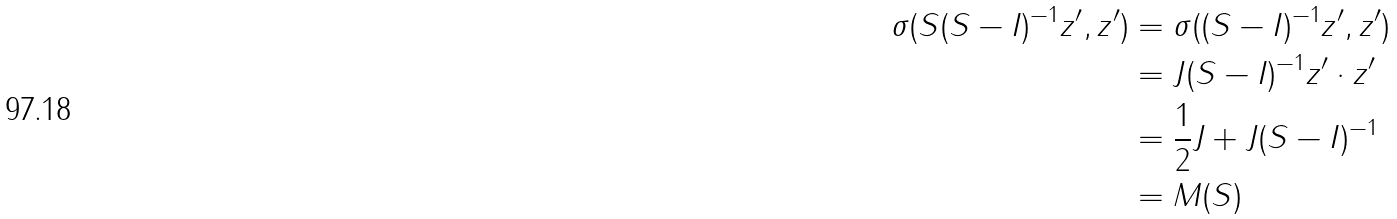<formula> <loc_0><loc_0><loc_500><loc_500>\sigma ( S ( S - I ) ^ { - 1 } z ^ { \prime } , z ^ { \prime } ) & = \sigma ( ( S - I ) ^ { - 1 } z ^ { \prime } , z ^ { \prime } ) \\ & = J ( S - I ) ^ { - 1 } z ^ { \prime } \cdot z ^ { \prime } \\ & = \frac { 1 } { 2 } J + J ( S - I ) ^ { - 1 } \\ & = M ( S )</formula> 